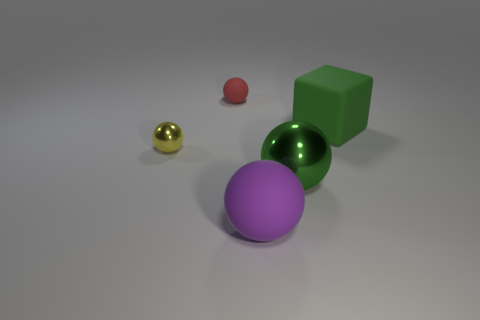Subtract all tiny red rubber spheres. How many spheres are left? 3 Subtract all yellow balls. How many balls are left? 3 Subtract all blocks. How many objects are left? 4 Subtract 1 spheres. How many spheres are left? 3 Add 3 large yellow cubes. How many large yellow cubes exist? 3 Add 3 green objects. How many objects exist? 8 Subtract 0 purple cylinders. How many objects are left? 5 Subtract all red balls. Subtract all blue blocks. How many balls are left? 3 Subtract all green cylinders. How many purple balls are left? 1 Subtract all small red rubber balls. Subtract all shiny objects. How many objects are left? 2 